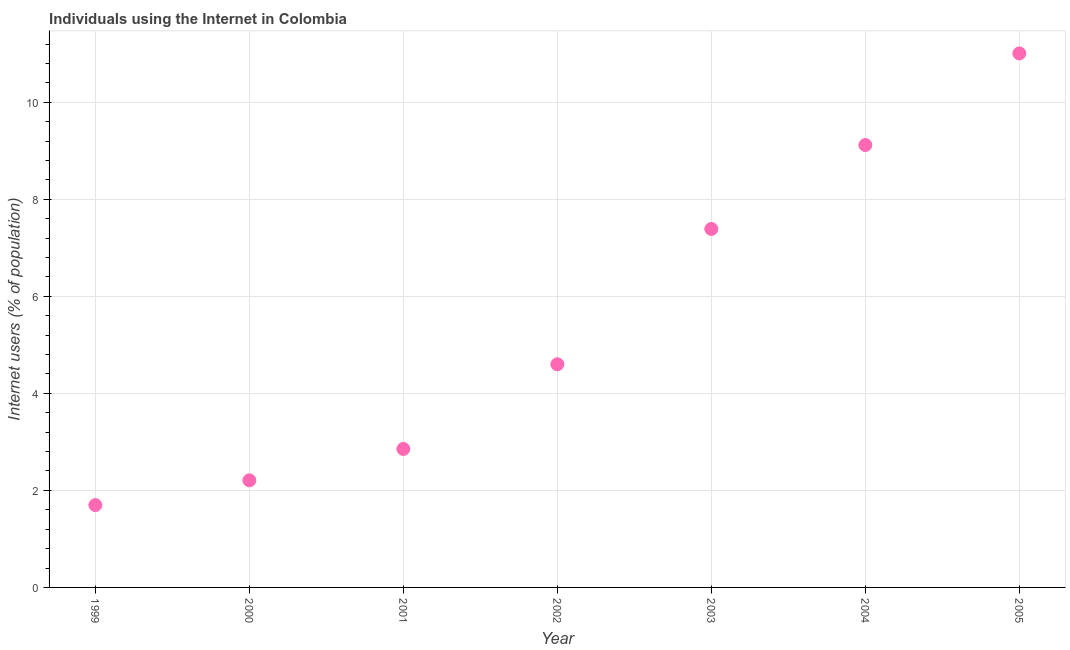What is the number of internet users in 2003?
Your answer should be compact. 7.39. Across all years, what is the maximum number of internet users?
Ensure brevity in your answer.  11.01. Across all years, what is the minimum number of internet users?
Keep it short and to the point. 1.7. What is the sum of the number of internet users?
Provide a short and direct response. 38.87. What is the difference between the number of internet users in 1999 and 2003?
Provide a short and direct response. -5.69. What is the average number of internet users per year?
Provide a short and direct response. 5.55. What is the median number of internet users?
Make the answer very short. 4.6. What is the ratio of the number of internet users in 2004 to that in 2005?
Your response must be concise. 0.83. Is the number of internet users in 2002 less than that in 2004?
Provide a short and direct response. Yes. Is the difference between the number of internet users in 1999 and 2005 greater than the difference between any two years?
Make the answer very short. Yes. What is the difference between the highest and the second highest number of internet users?
Your answer should be compact. 1.89. Is the sum of the number of internet users in 2002 and 2004 greater than the maximum number of internet users across all years?
Your response must be concise. Yes. What is the difference between the highest and the lowest number of internet users?
Offer a terse response. 9.31. In how many years, is the number of internet users greater than the average number of internet users taken over all years?
Provide a succinct answer. 3. How many dotlines are there?
Your answer should be compact. 1. What is the difference between two consecutive major ticks on the Y-axis?
Offer a very short reply. 2. Does the graph contain any zero values?
Offer a terse response. No. Does the graph contain grids?
Give a very brief answer. Yes. What is the title of the graph?
Ensure brevity in your answer.  Individuals using the Internet in Colombia. What is the label or title of the X-axis?
Ensure brevity in your answer.  Year. What is the label or title of the Y-axis?
Your answer should be very brief. Internet users (% of population). What is the Internet users (% of population) in 1999?
Keep it short and to the point. 1.7. What is the Internet users (% of population) in 2000?
Ensure brevity in your answer.  2.21. What is the Internet users (% of population) in 2001?
Offer a terse response. 2.85. What is the Internet users (% of population) in 2002?
Provide a succinct answer. 4.6. What is the Internet users (% of population) in 2003?
Ensure brevity in your answer.  7.39. What is the Internet users (% of population) in 2004?
Ensure brevity in your answer.  9.12. What is the Internet users (% of population) in 2005?
Ensure brevity in your answer.  11.01. What is the difference between the Internet users (% of population) in 1999 and 2000?
Offer a terse response. -0.51. What is the difference between the Internet users (% of population) in 1999 and 2001?
Your answer should be very brief. -1.16. What is the difference between the Internet users (% of population) in 1999 and 2002?
Offer a terse response. -2.9. What is the difference between the Internet users (% of population) in 1999 and 2003?
Your answer should be very brief. -5.69. What is the difference between the Internet users (% of population) in 1999 and 2004?
Your response must be concise. -7.42. What is the difference between the Internet users (% of population) in 1999 and 2005?
Provide a succinct answer. -9.31. What is the difference between the Internet users (% of population) in 2000 and 2001?
Ensure brevity in your answer.  -0.65. What is the difference between the Internet users (% of population) in 2000 and 2002?
Your response must be concise. -2.39. What is the difference between the Internet users (% of population) in 2000 and 2003?
Give a very brief answer. -5.18. What is the difference between the Internet users (% of population) in 2000 and 2004?
Make the answer very short. -6.91. What is the difference between the Internet users (% of population) in 2000 and 2005?
Your answer should be very brief. -8.8. What is the difference between the Internet users (% of population) in 2001 and 2002?
Keep it short and to the point. -1.75. What is the difference between the Internet users (% of population) in 2001 and 2003?
Offer a very short reply. -4.53. What is the difference between the Internet users (% of population) in 2001 and 2004?
Offer a very short reply. -6.26. What is the difference between the Internet users (% of population) in 2001 and 2005?
Offer a very short reply. -8.15. What is the difference between the Internet users (% of population) in 2002 and 2003?
Your answer should be very brief. -2.79. What is the difference between the Internet users (% of population) in 2002 and 2004?
Provide a short and direct response. -4.52. What is the difference between the Internet users (% of population) in 2002 and 2005?
Offer a terse response. -6.41. What is the difference between the Internet users (% of population) in 2003 and 2004?
Make the answer very short. -1.73. What is the difference between the Internet users (% of population) in 2003 and 2005?
Your response must be concise. -3.62. What is the difference between the Internet users (% of population) in 2004 and 2005?
Offer a very short reply. -1.89. What is the ratio of the Internet users (% of population) in 1999 to that in 2000?
Offer a very short reply. 0.77. What is the ratio of the Internet users (% of population) in 1999 to that in 2001?
Make the answer very short. 0.59. What is the ratio of the Internet users (% of population) in 1999 to that in 2002?
Offer a very short reply. 0.37. What is the ratio of the Internet users (% of population) in 1999 to that in 2003?
Your answer should be very brief. 0.23. What is the ratio of the Internet users (% of population) in 1999 to that in 2004?
Offer a very short reply. 0.19. What is the ratio of the Internet users (% of population) in 1999 to that in 2005?
Give a very brief answer. 0.15. What is the ratio of the Internet users (% of population) in 2000 to that in 2001?
Make the answer very short. 0.77. What is the ratio of the Internet users (% of population) in 2000 to that in 2002?
Provide a short and direct response. 0.48. What is the ratio of the Internet users (% of population) in 2000 to that in 2003?
Your answer should be compact. 0.3. What is the ratio of the Internet users (% of population) in 2000 to that in 2004?
Provide a short and direct response. 0.24. What is the ratio of the Internet users (% of population) in 2000 to that in 2005?
Offer a terse response. 0.2. What is the ratio of the Internet users (% of population) in 2001 to that in 2002?
Ensure brevity in your answer.  0.62. What is the ratio of the Internet users (% of population) in 2001 to that in 2003?
Provide a succinct answer. 0.39. What is the ratio of the Internet users (% of population) in 2001 to that in 2004?
Give a very brief answer. 0.31. What is the ratio of the Internet users (% of population) in 2001 to that in 2005?
Your answer should be compact. 0.26. What is the ratio of the Internet users (% of population) in 2002 to that in 2003?
Your answer should be compact. 0.62. What is the ratio of the Internet users (% of population) in 2002 to that in 2004?
Offer a terse response. 0.5. What is the ratio of the Internet users (% of population) in 2002 to that in 2005?
Your answer should be compact. 0.42. What is the ratio of the Internet users (% of population) in 2003 to that in 2004?
Keep it short and to the point. 0.81. What is the ratio of the Internet users (% of population) in 2003 to that in 2005?
Give a very brief answer. 0.67. What is the ratio of the Internet users (% of population) in 2004 to that in 2005?
Your response must be concise. 0.83. 